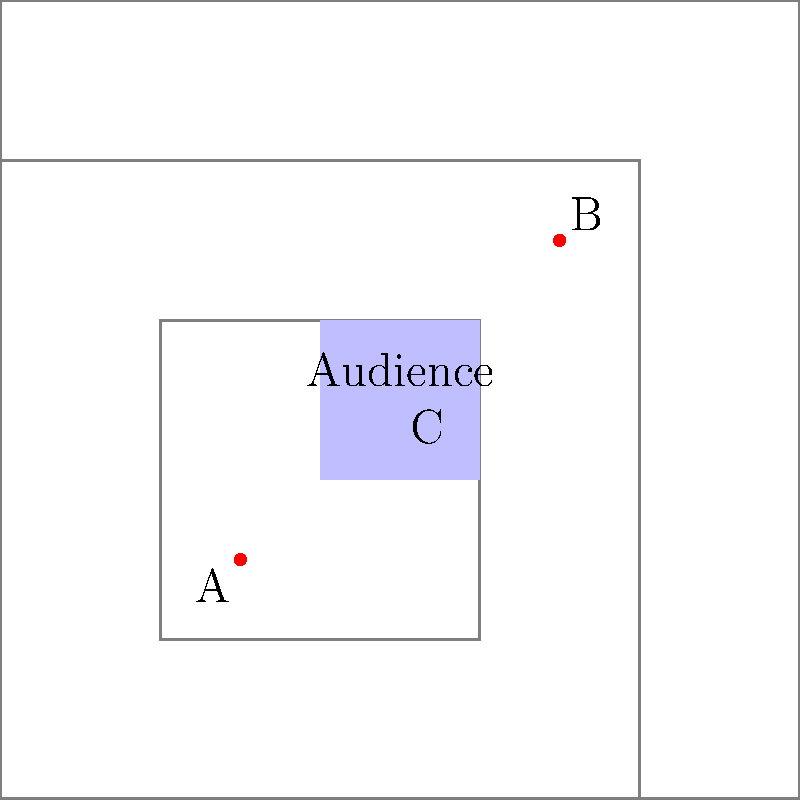As a street musician planning a performance, you're analyzing the acoustic environment of a small plaza. The diagram shows three potential speaker placements (A, B, and C) within different acoustic zones. Given that the blue square represents the audience area, which speaker position would provide the most balanced sound distribution for your performance? To determine the best speaker placement, we need to consider the following factors:

1. Distance from the audience: The closer the speaker is to the audience, the louder and clearer the sound will be.

2. Reflections: Sound waves bounce off surfaces, which can create echoes or amplify the sound in certain areas.

3. Coverage: The speaker should be positioned to cover the entire audience area evenly.

Let's analyze each position:

A (30,30):
- Closest to the audience area
- Located in the largest acoustic zone, which might cause more reflections
- Positioned at one corner of the audience area, potentially creating uneven sound distribution

B (70,70):
- Furthest from the audience area
- Located in a smaller acoustic zone, which might reduce unwanted reflections
- Positioned diagonally opposite to the audience area, potentially creating uneven sound distribution

C (50,50):
- Centrally located, equidistant from all parts of the audience area
- Positioned in a medium-sized acoustic zone, balancing reflections
- Provides the most even coverage for the audience area

Based on these observations, position C (50,50) would provide the most balanced sound distribution for the performance. It offers:

1. Even distance to all parts of the audience area
2. Balanced reflections from the surrounding environment
3. Optimal coverage of the entire audience area

This position allows for the best compromise between proximity, reflection control, and even sound distribution, making it the ideal choice for a street performance in this acoustic environment.
Answer: C (50,50) 